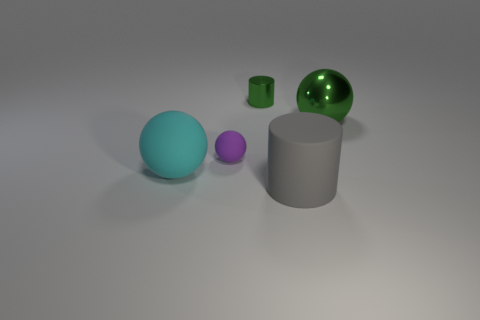How do the shapes in this image interact with each other? The shapes in this image exhibit a harmonious arrangement. The large cylinder and sphere create a visual anchor in the composition, with the tiny cylinder and small sphere positioned to guide the viewer's gaze across the scene. The variation in size and spatial distribution offers a pleasing dynamic that conveys both balance and diversity, reflecting a thoughtful juxtaposition of geometric forms. 